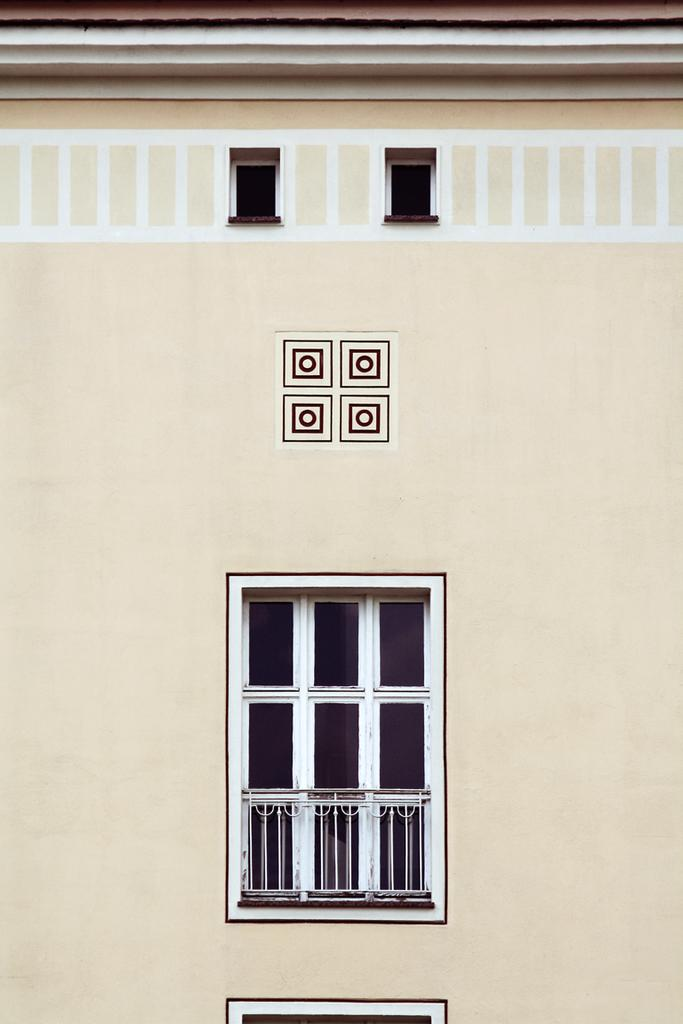What can be seen in the image? There is a wall in the image. What feature does the wall have? The wall has windows. What type of powder is being used to attempt to break through the wall in the image? There is no powder or attempt to break through the wall in the image; it simply shows a wall with windows. 